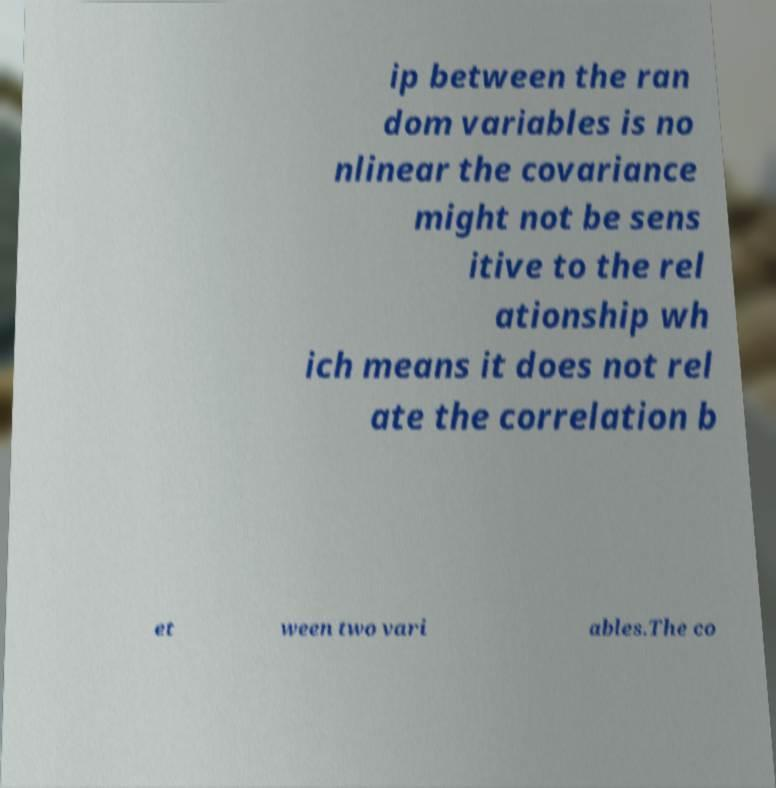Can you read and provide the text displayed in the image?This photo seems to have some interesting text. Can you extract and type it out for me? ip between the ran dom variables is no nlinear the covariance might not be sens itive to the rel ationship wh ich means it does not rel ate the correlation b et ween two vari ables.The co 